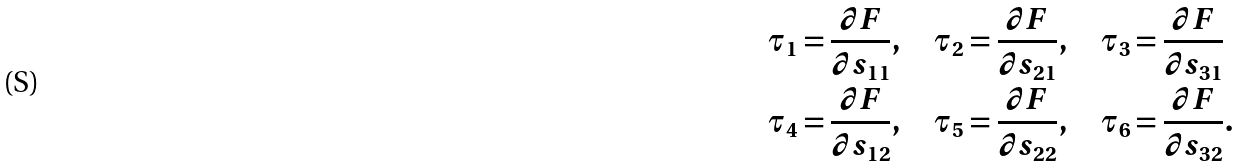Convert formula to latex. <formula><loc_0><loc_0><loc_500><loc_500>& \tau _ { 1 } = \frac { \partial F } { \partial s _ { 1 1 } } , \quad \tau _ { 2 } = \frac { \partial F } { \partial s _ { 2 1 } } , \quad \tau _ { 3 } = \frac { \partial F } { \partial s _ { 3 1 } } \\ & \tau _ { 4 } = \frac { \partial F } { \partial s _ { 1 2 } } , \quad \tau _ { 5 } = \frac { \partial F } { \partial s _ { 2 2 } } , \quad \tau _ { 6 } = \frac { \partial F } { \partial s _ { 3 2 } } .</formula> 